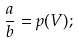Convert formula to latex. <formula><loc_0><loc_0><loc_500><loc_500>\frac { a } { b } = p ( V ) ;</formula> 